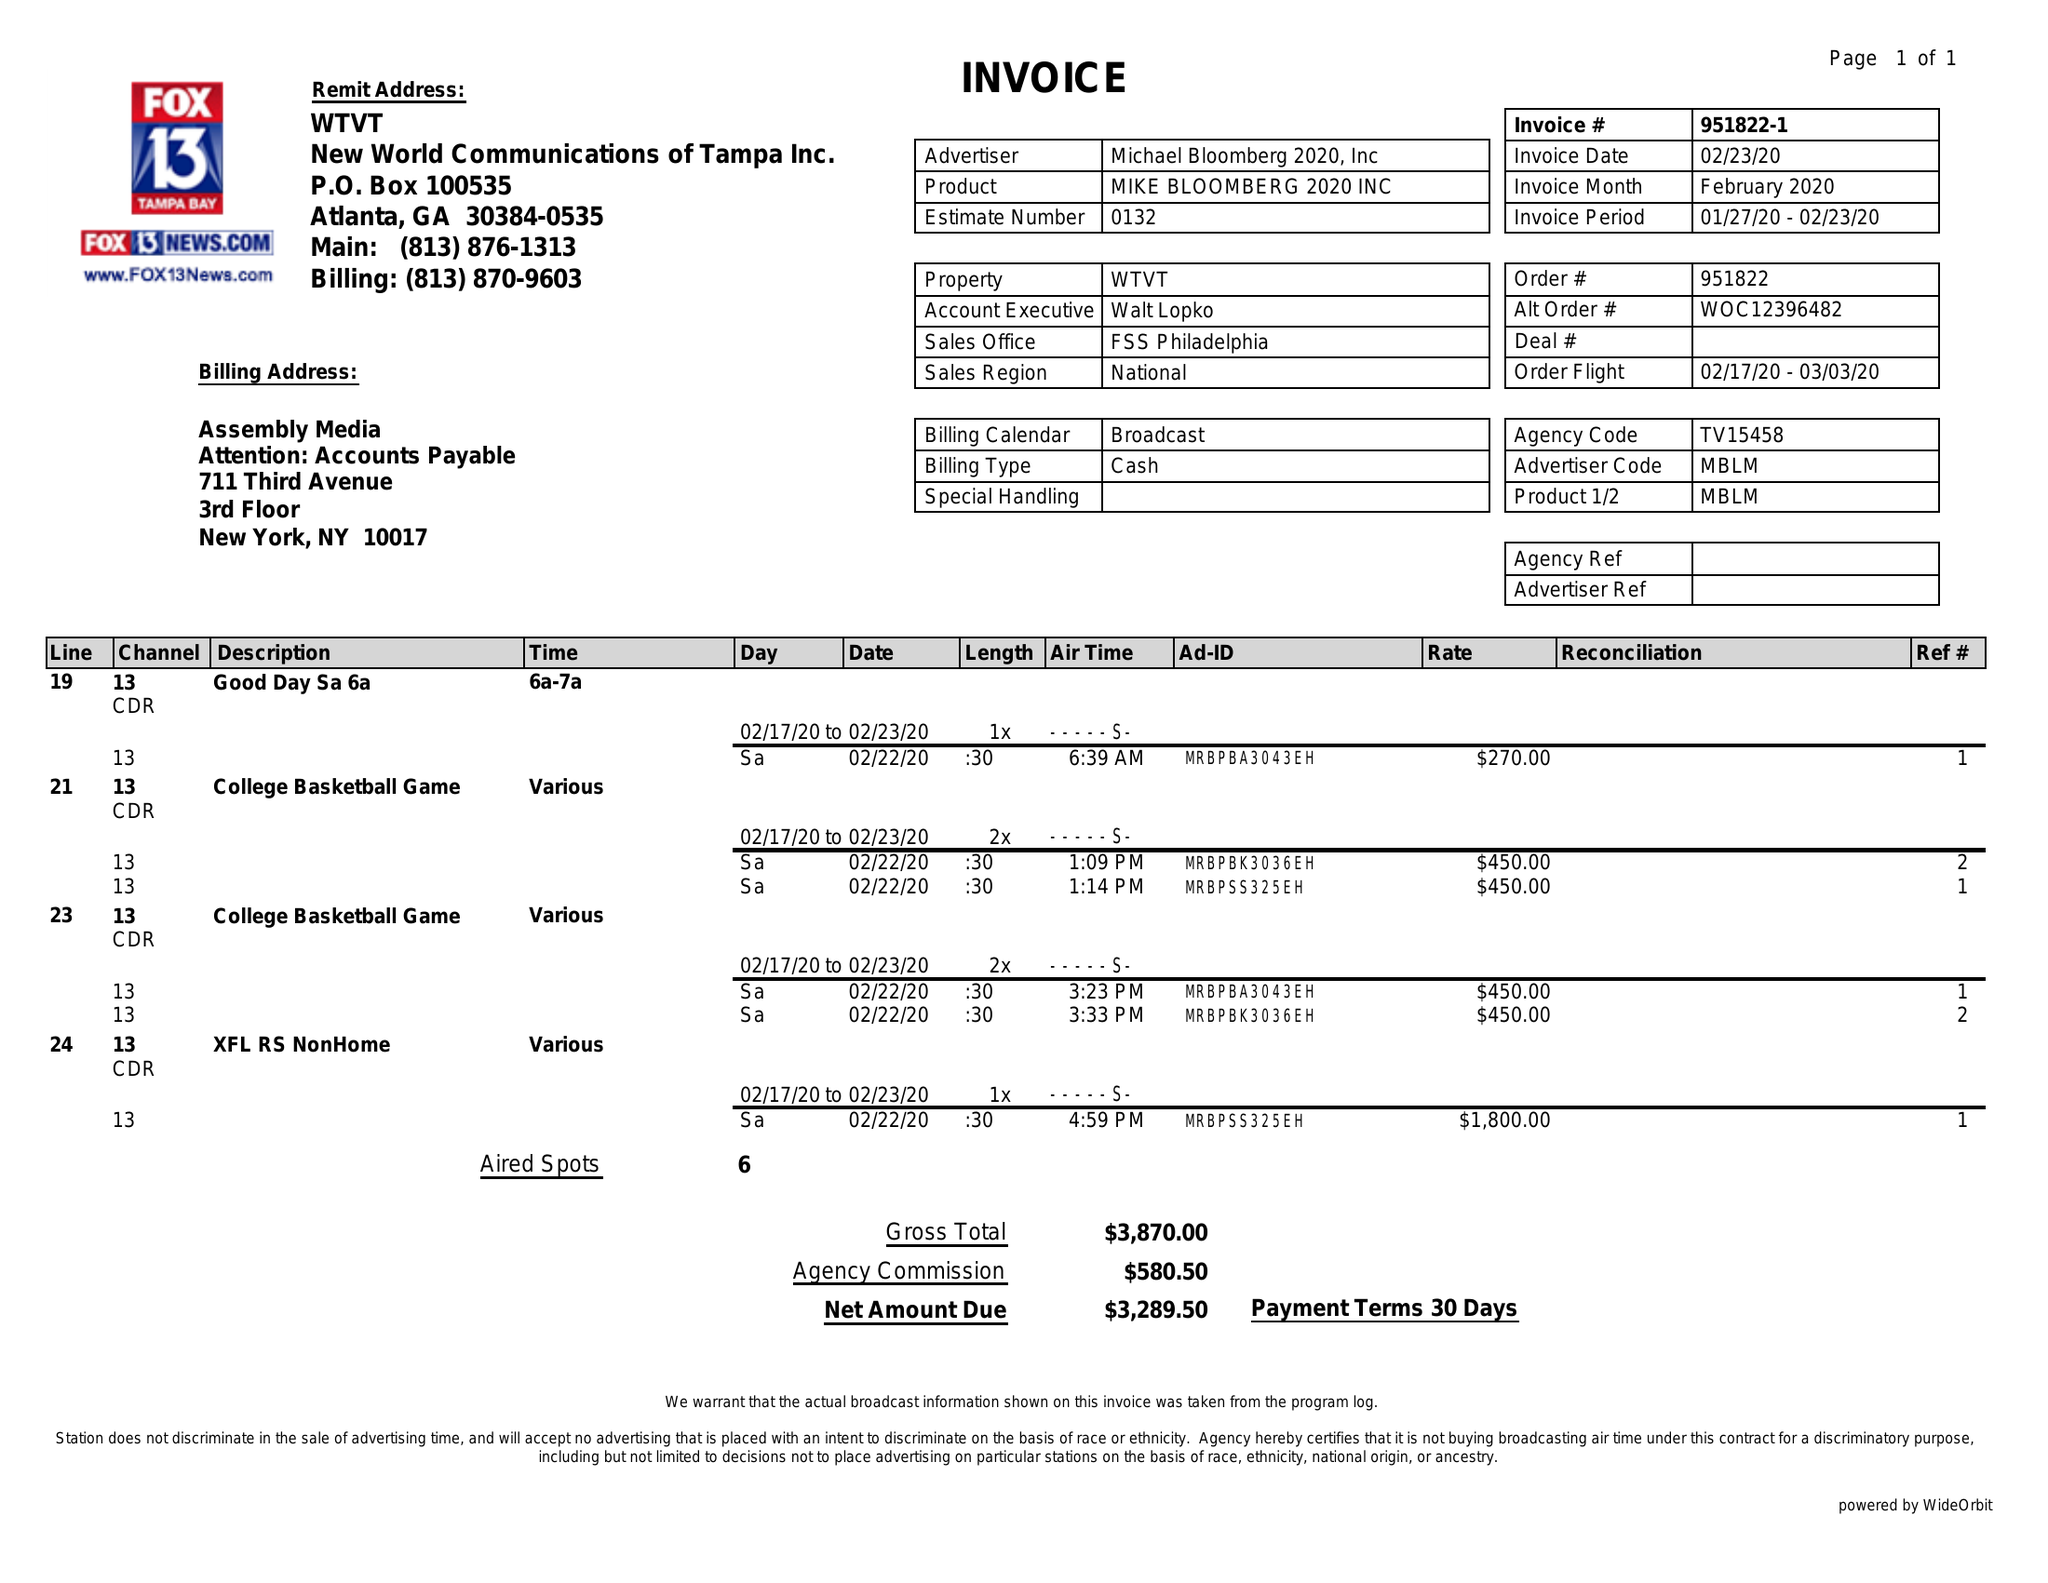What is the value for the advertiser?
Answer the question using a single word or phrase. MICHAEL BLOOMBERG 2020, INC 